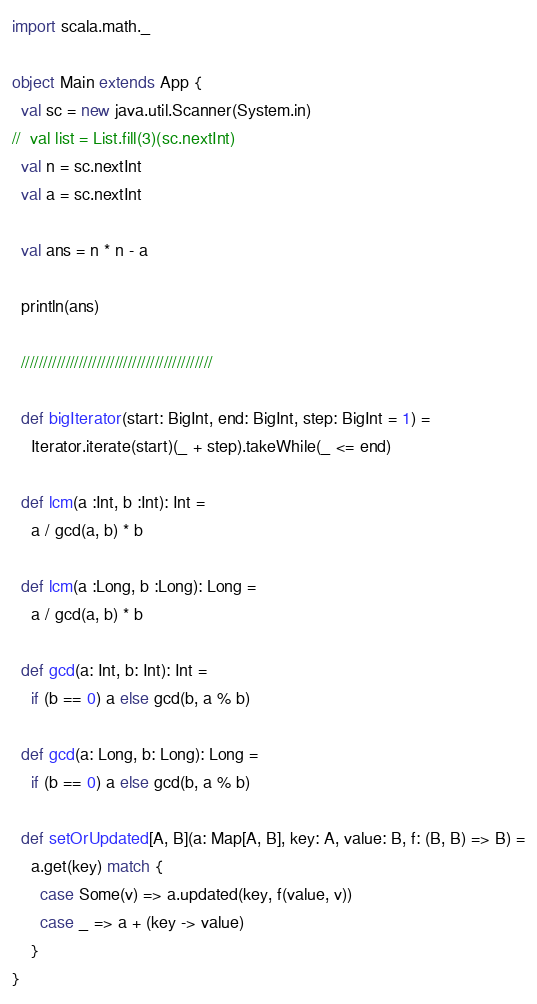Convert code to text. <code><loc_0><loc_0><loc_500><loc_500><_Scala_>import scala.math._

object Main extends App {
  val sc = new java.util.Scanner(System.in)
//  val list = List.fill(3)(sc.nextInt)
  val n = sc.nextInt
  val a = sc.nextInt

  val ans = n * n - a

  println(ans)

  ///////////////////////////////////////////

  def bigIterator(start: BigInt, end: BigInt, step: BigInt = 1) =
    Iterator.iterate(start)(_ + step).takeWhile(_ <= end)

  def lcm(a :Int, b :Int): Int =
    a / gcd(a, b) * b

  def lcm(a :Long, b :Long): Long =
    a / gcd(a, b) * b

  def gcd(a: Int, b: Int): Int =
    if (b == 0) a else gcd(b, a % b)

  def gcd(a: Long, b: Long): Long =
    if (b == 0) a else gcd(b, a % b)

  def setOrUpdated[A, B](a: Map[A, B], key: A, value: B, f: (B, B) => B) =
    a.get(key) match {
      case Some(v) => a.updated(key, f(value, v))
      case _ => a + (key -> value)
    }
}</code> 